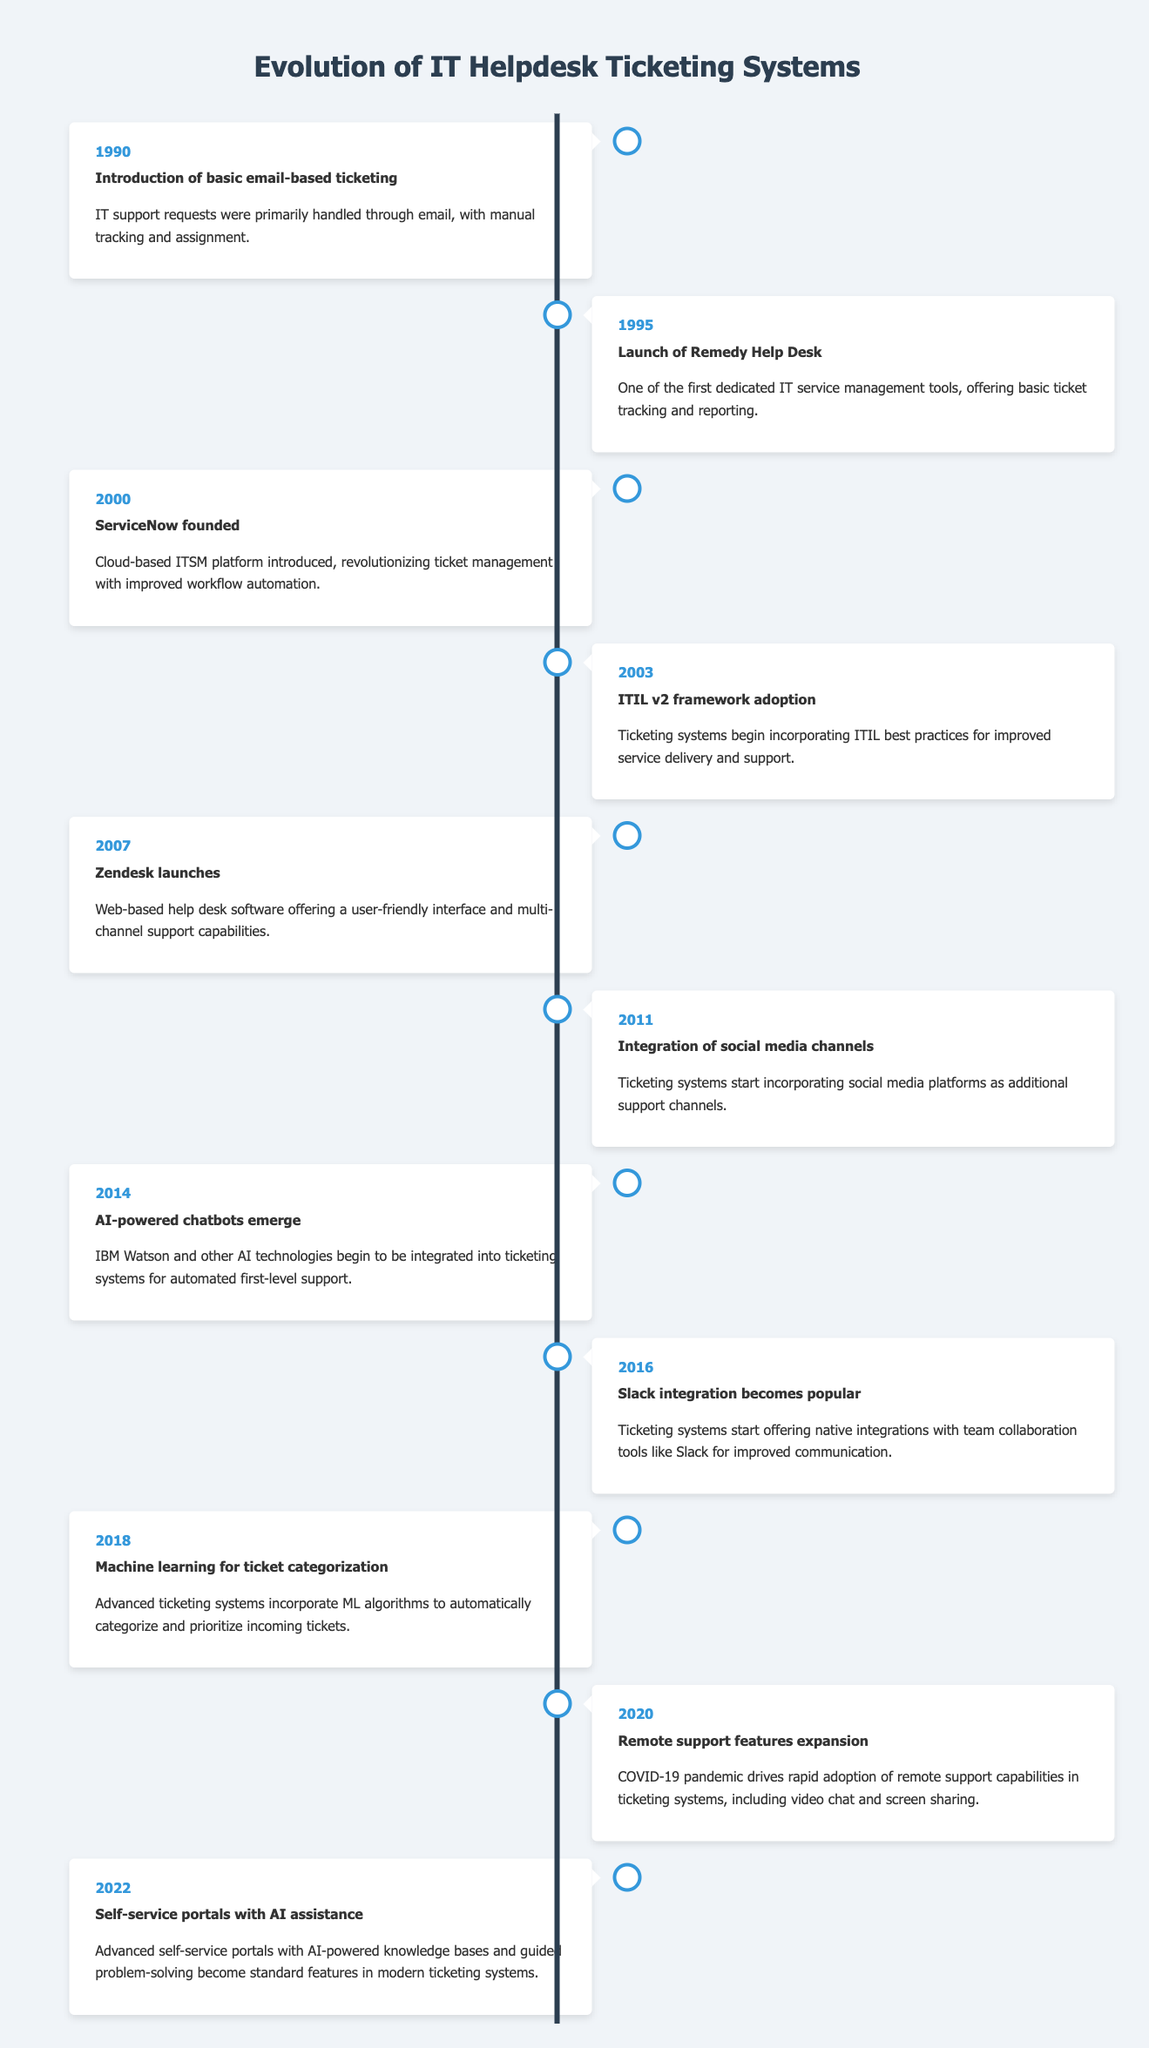What year did the launch of Remedy Help Desk occur? The table states that the launch of Remedy Help Desk happened in the year 1995. We're directly retrieving the event's year from the table.
Answer: 1995 What was the first cloud-based ITSM platform introduced? According to the table, ServiceNow, founded in the year 2000, is noted as the first cloud-based ITSM platform introduced.
Answer: ServiceNow Which ticketing system integrated social media channels first? The data mentions the integration of social media channels as occurring in 2011, but it does not specify which specific system integrated them first. Hence, a concrete answer cannot be given.
Answer: No How many years passed between the introduction of email-based ticketing in 1990 and the launch of Zendesk in 2007? From 1990 to 2007 is a span of 17 years. By subtracting 1990 from 2007, we find that the time difference is 17 years.
Answer: 17 Was AI integration present in ticketing systems before 2014? The table shows that AI-powered chatbots emerged in 2014, and no AI integration in ticketing systems is mentioned prior to this date, implying it was not present before this time.
Answer: No Which advancements in ticketing systems occurred after 2011? The table indicates that after 2011, there were the emergence of AI-powered chatbots in 2014 and the introduction of machine learning for ticket categorization in 2018, followed by the expansion of remote support features in 2020, and self-service portals with AI assistance in 2022. The events listed confirm these advancements were after 2011.
Answer: 4 Can you name the event that occurred in 2022 regarding IT helpdesk systems? The table notes that in 2022, self-service portals with AI assistance became standard features in modern ticketing systems, directly answering the query based on the data presented.
Answer: Self-service portals with AI assistance What is the primary focus of ticketing systems that began adopting ITIL best practices? The description in the table for the event in 2003 states that ticketing systems began incorporating ITIL best practices for improved service delivery and support. This indicates the primary focus was on service delivery and support.
Answer: Service delivery and support How did the COVID-19 pandemic influence ticketing systems as per the timeline? As per the data, the COVID-19 pandemic led to a rapid adoption of remote support capabilities in ticketing systems by 2020, highlighting the influence of the pandemic on enhancements in this area.
Answer: Remote support capabilities expansion What trend was initiated in ticketing systems by 2003? The event described for that year indicates that ticketing systems began incorporating ITIL best practices, which represents a significant trend towards enhancing support and service delivery, as documented in the timeline.
Answer: ITIL best practices incorporation 